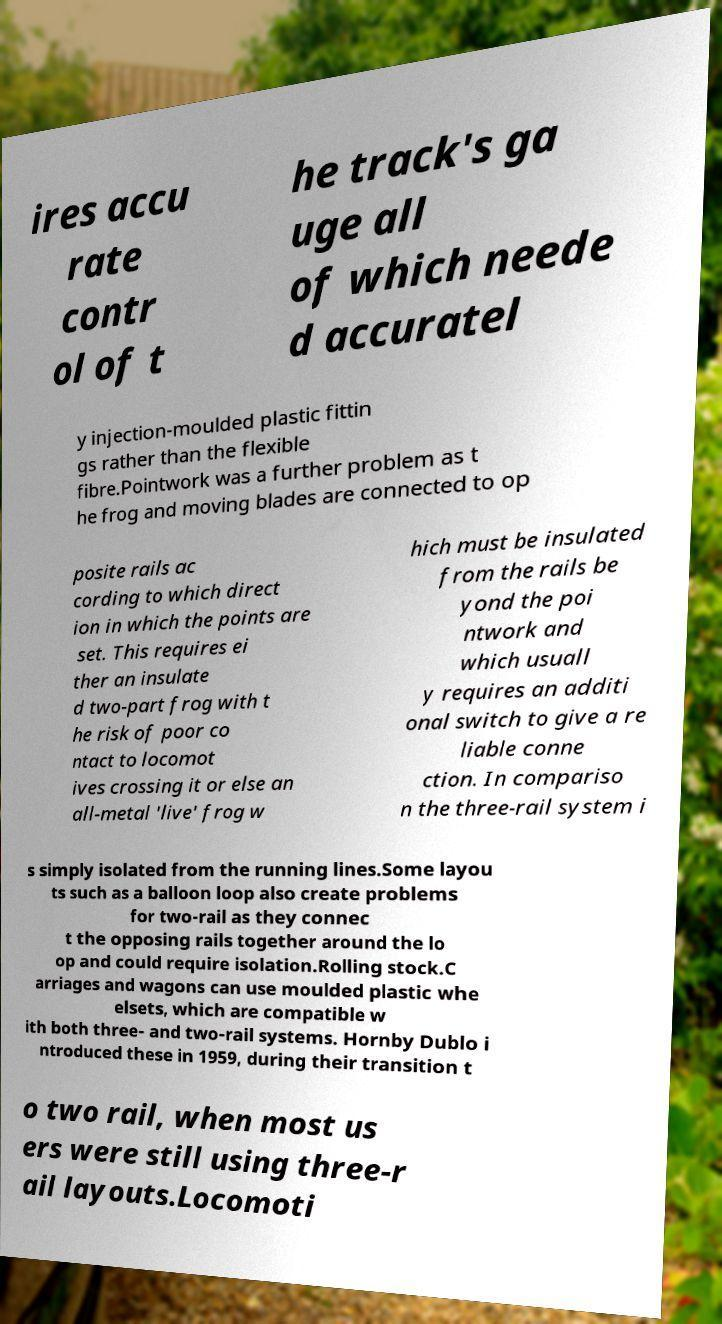Can you accurately transcribe the text from the provided image for me? ires accu rate contr ol of t he track's ga uge all of which neede d accuratel y injection-moulded plastic fittin gs rather than the flexible fibre.Pointwork was a further problem as t he frog and moving blades are connected to op posite rails ac cording to which direct ion in which the points are set. This requires ei ther an insulate d two-part frog with t he risk of poor co ntact to locomot ives crossing it or else an all-metal 'live' frog w hich must be insulated from the rails be yond the poi ntwork and which usuall y requires an additi onal switch to give a re liable conne ction. In compariso n the three-rail system i s simply isolated from the running lines.Some layou ts such as a balloon loop also create problems for two-rail as they connec t the opposing rails together around the lo op and could require isolation.Rolling stock.C arriages and wagons can use moulded plastic whe elsets, which are compatible w ith both three- and two-rail systems. Hornby Dublo i ntroduced these in 1959, during their transition t o two rail, when most us ers were still using three-r ail layouts.Locomoti 